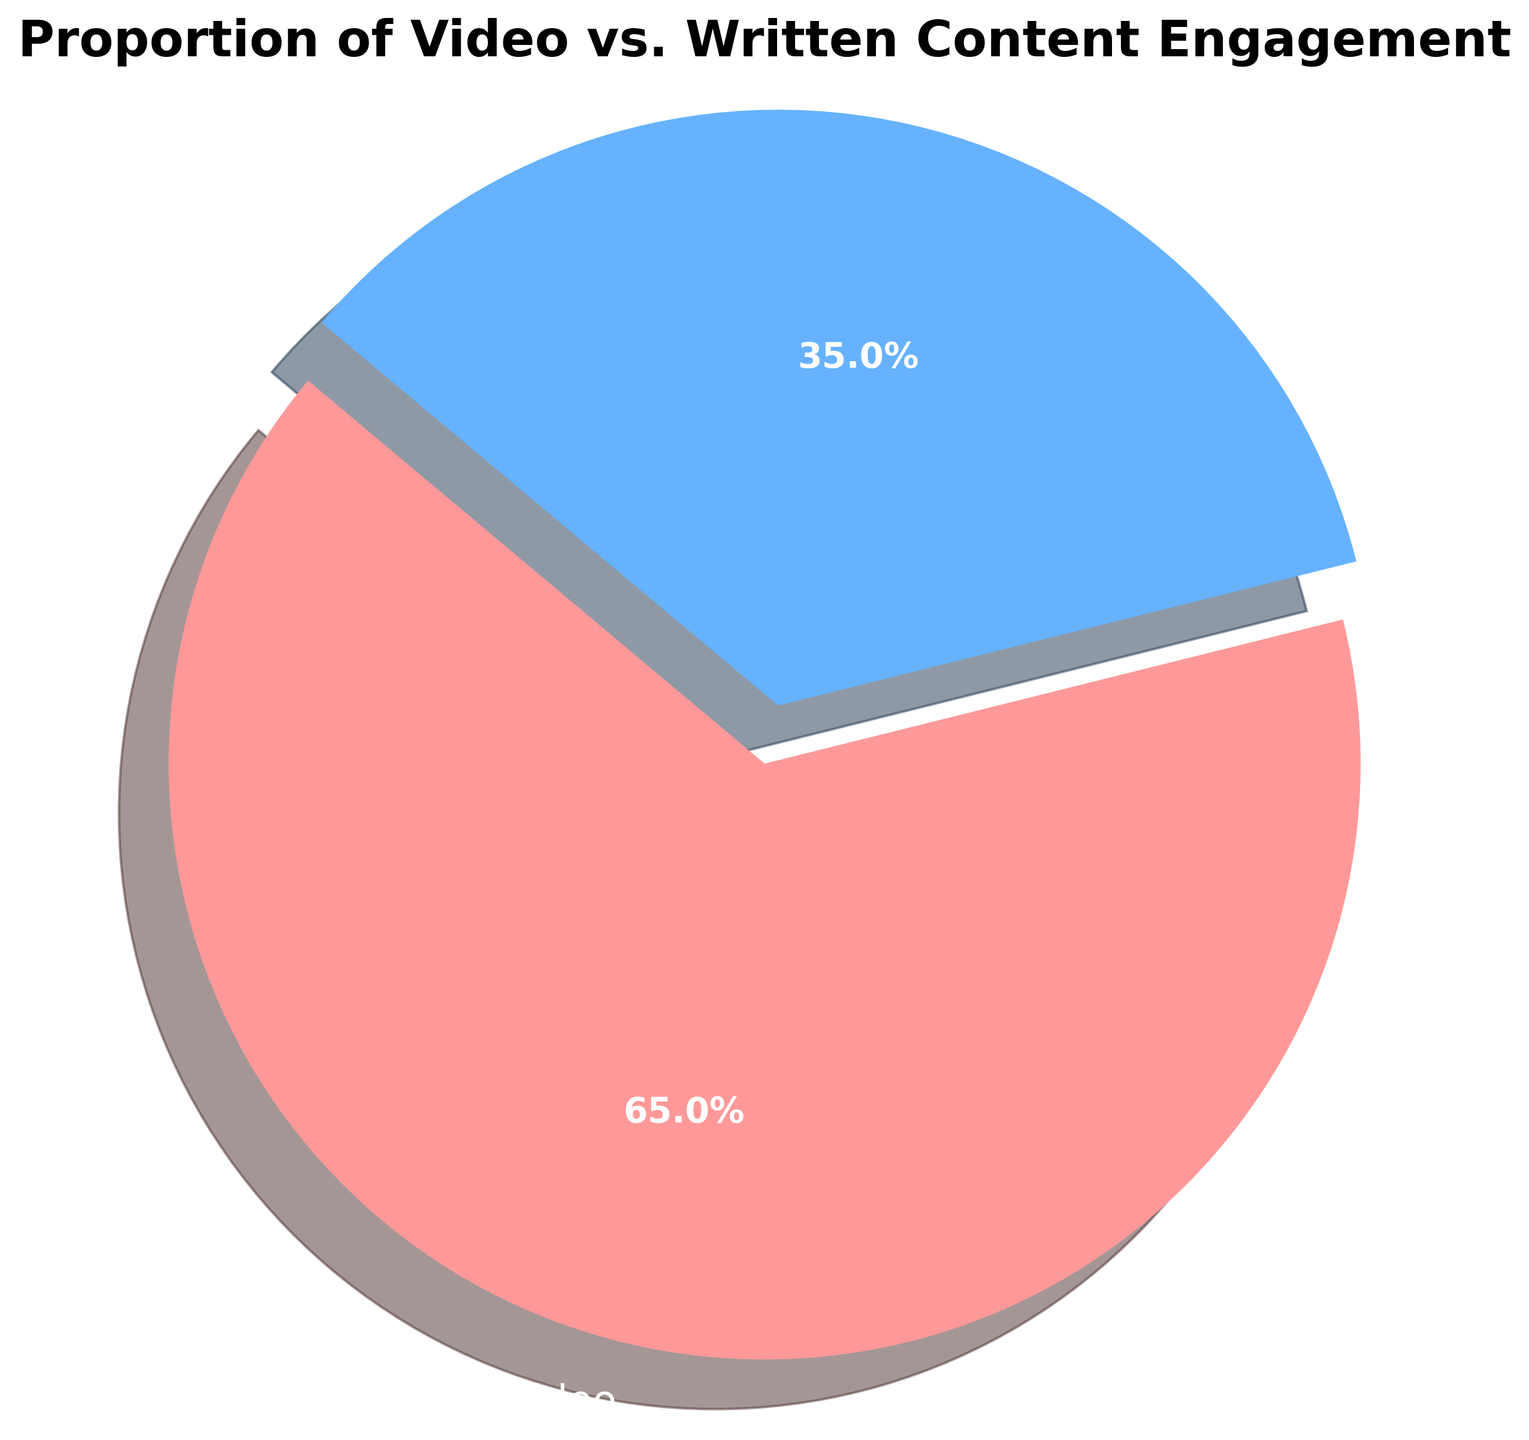What percentage of engagement is attributed to video content? The pie chart shows two slices with their respective percentages. The percentage for the 'Video' slice is indicated directly on the chart as 65.0%.
Answer: 65.0% Which content type has a higher engagement rate, video or written? The pie chart shows two content types: Video and Written. The 'Video' slice occupies a larger portion of the chart (65.0%) compared to the 'Written' slice (35.0%).
Answer: Video How much higher is the engagement rate for video content compared to written content? The engagement rate for video content is 65.0%, and for written content, it is 35.0%. Subtract the written percentage from the video percentage: 65.0% - 35.0% = 30.0%.
Answer: 30.0% What is the ratio of video content engagement to written content engagement? The engagement rate for video content is 65.0%, and for written content, it is 35.0%. To find the ratio, divide the video engagement rate by the written engagement rate: 65.0 / 35.0 ≈ 1.857.
Answer: 1.857 If the total engagement is represented by the entire pie, how many degrees of the pie chart does the video content occupy? A full pie chart represents 360 degrees. Video content takes up 65.0% of the pie. Calculate the angle by multiplying 360 degrees by 0.65: 360 * 0.65 = 234 degrees.
Answer: 234 degrees Identify the color used to represent written content in the pie chart. The pie chart uses distinct colors for video and written content. The slice labeled 'Written' is shown in blue.
Answer: Blue Estimate the visual difference in size between the two slices of the pie chart. The 'Video' slice looks significantly larger than the 'Written' slice. By the percentages given (65.0% for video and 35.0% for written), the video slice visually appears almost twice as large as the written slice.
Answer: Almost double If the proportion of written content increased to 50%, what would be the new engagement rate for video content, assuming the total remains 100%? If written content increases to 50%, the total must sum to 100%. Therefore, the new engagement rate for video content would be 100% - 50% = 50%.
Answer: 50% 